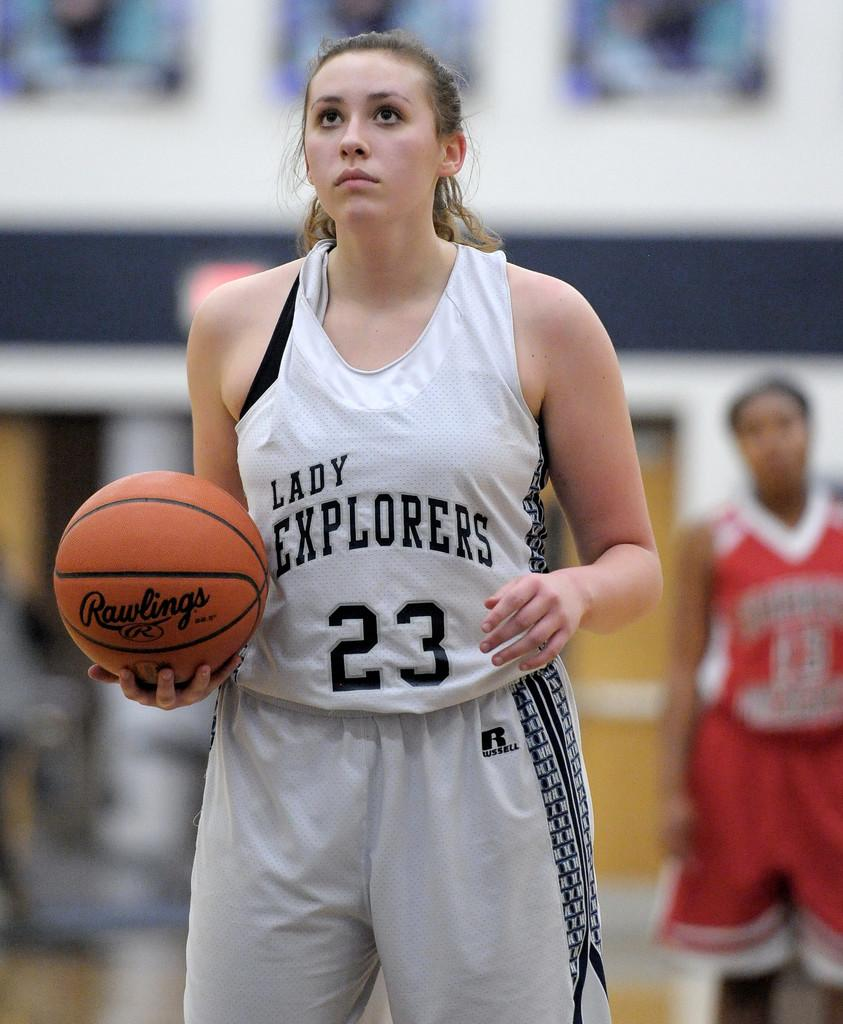Provide a one-sentence caption for the provided image. A basketball player has the team name Lady Explorers on her jersey. 